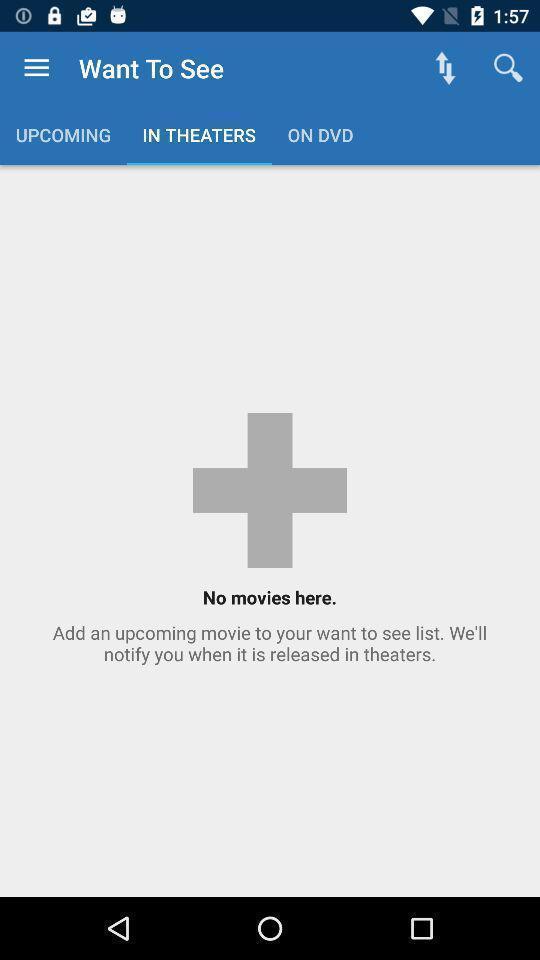Summarize the main components in this picture. Theaters page in a movies app. 